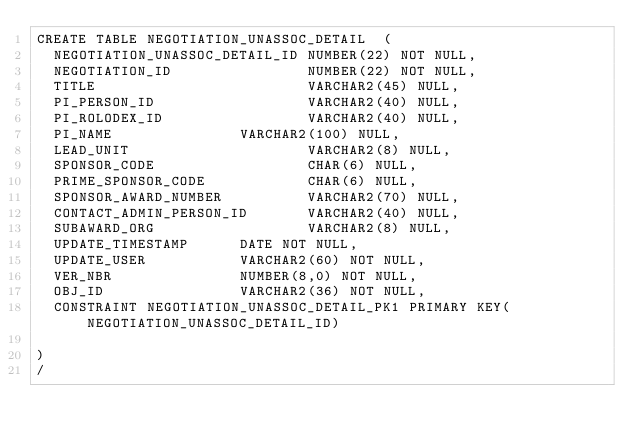<code> <loc_0><loc_0><loc_500><loc_500><_SQL_>CREATE TABLE NEGOTIATION_UNASSOC_DETAIL  ( 
	NEGOTIATION_UNASSOC_DETAIL_ID	NUMBER(22) NOT NULL,
	NEGOTIATION_ID               	NUMBER(22) NOT NULL,
	TITLE                        	VARCHAR2(45) NULL,
	PI_PERSON_ID                 	VARCHAR2(40) NULL,
	PI_ROLODEX_ID                	VARCHAR2(40) NULL,
	PI_NAME						    VARCHAR2(100) NULL,
	LEAD_UNIT                    	VARCHAR2(8) NULL,
	SPONSOR_CODE                 	CHAR(6) NULL,
	PRIME_SPONSOR_CODE           	CHAR(6) NULL,
	SPONSOR_AWARD_NUMBER         	VARCHAR2(70) NULL,
	CONTACT_ADMIN_PERSON_ID      	VARCHAR2(40) NULL,
	SUBAWARD_ORG                 	VARCHAR2(8) NULL,
	UPDATE_TIMESTAMP     	DATE NOT NULL,
	UPDATE_USER          	VARCHAR2(60) NOT NULL,
	VER_NBR              	NUMBER(8,0) NOT NULL,
	OBJ_ID               	VARCHAR2(36) NOT NULL,
	CONSTRAINT NEGOTIATION_UNASSOC_DETAIL_PK1 PRIMARY KEY(NEGOTIATION_UNASSOC_DETAIL_ID)
	
)
/
</code> 